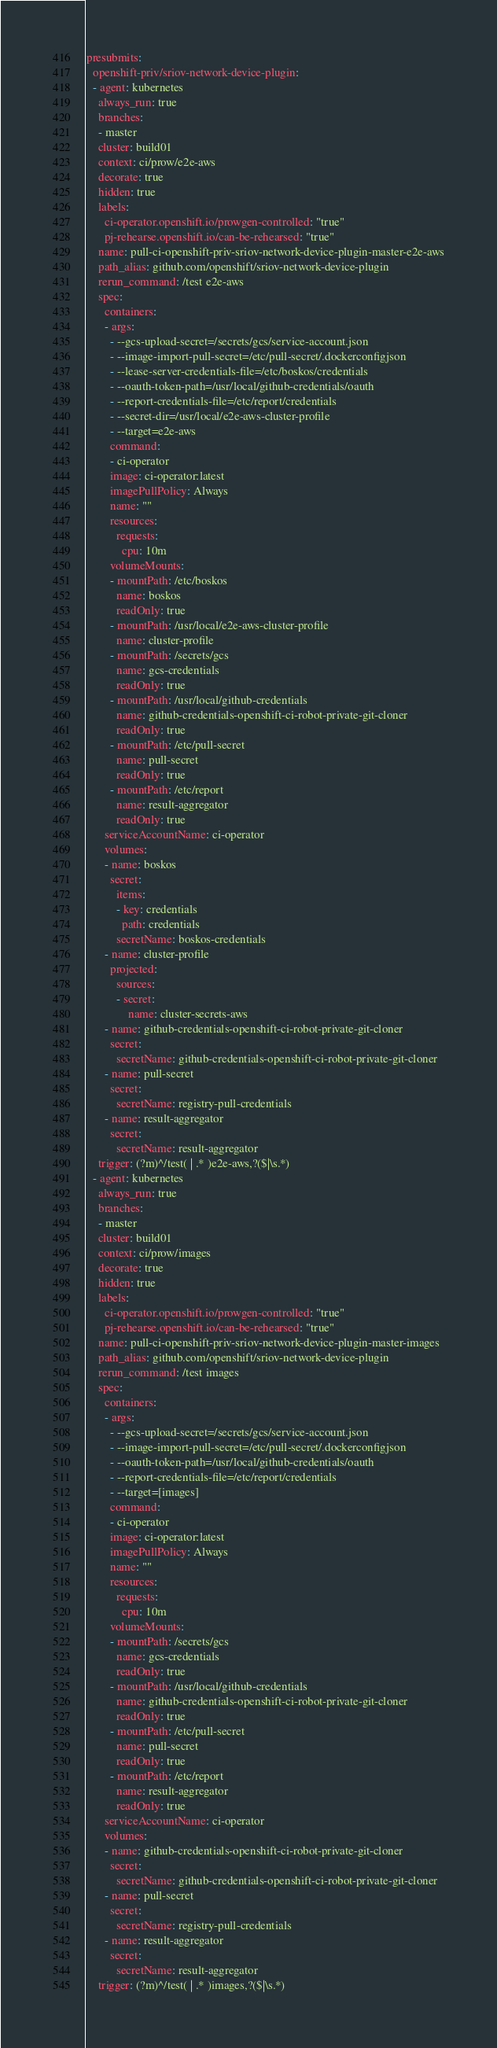Convert code to text. <code><loc_0><loc_0><loc_500><loc_500><_YAML_>presubmits:
  openshift-priv/sriov-network-device-plugin:
  - agent: kubernetes
    always_run: true
    branches:
    - master
    cluster: build01
    context: ci/prow/e2e-aws
    decorate: true
    hidden: true
    labels:
      ci-operator.openshift.io/prowgen-controlled: "true"
      pj-rehearse.openshift.io/can-be-rehearsed: "true"
    name: pull-ci-openshift-priv-sriov-network-device-plugin-master-e2e-aws
    path_alias: github.com/openshift/sriov-network-device-plugin
    rerun_command: /test e2e-aws
    spec:
      containers:
      - args:
        - --gcs-upload-secret=/secrets/gcs/service-account.json
        - --image-import-pull-secret=/etc/pull-secret/.dockerconfigjson
        - --lease-server-credentials-file=/etc/boskos/credentials
        - --oauth-token-path=/usr/local/github-credentials/oauth
        - --report-credentials-file=/etc/report/credentials
        - --secret-dir=/usr/local/e2e-aws-cluster-profile
        - --target=e2e-aws
        command:
        - ci-operator
        image: ci-operator:latest
        imagePullPolicy: Always
        name: ""
        resources:
          requests:
            cpu: 10m
        volumeMounts:
        - mountPath: /etc/boskos
          name: boskos
          readOnly: true
        - mountPath: /usr/local/e2e-aws-cluster-profile
          name: cluster-profile
        - mountPath: /secrets/gcs
          name: gcs-credentials
          readOnly: true
        - mountPath: /usr/local/github-credentials
          name: github-credentials-openshift-ci-robot-private-git-cloner
          readOnly: true
        - mountPath: /etc/pull-secret
          name: pull-secret
          readOnly: true
        - mountPath: /etc/report
          name: result-aggregator
          readOnly: true
      serviceAccountName: ci-operator
      volumes:
      - name: boskos
        secret:
          items:
          - key: credentials
            path: credentials
          secretName: boskos-credentials
      - name: cluster-profile
        projected:
          sources:
          - secret:
              name: cluster-secrets-aws
      - name: github-credentials-openshift-ci-robot-private-git-cloner
        secret:
          secretName: github-credentials-openshift-ci-robot-private-git-cloner
      - name: pull-secret
        secret:
          secretName: registry-pull-credentials
      - name: result-aggregator
        secret:
          secretName: result-aggregator
    trigger: (?m)^/test( | .* )e2e-aws,?($|\s.*)
  - agent: kubernetes
    always_run: true
    branches:
    - master
    cluster: build01
    context: ci/prow/images
    decorate: true
    hidden: true
    labels:
      ci-operator.openshift.io/prowgen-controlled: "true"
      pj-rehearse.openshift.io/can-be-rehearsed: "true"
    name: pull-ci-openshift-priv-sriov-network-device-plugin-master-images
    path_alias: github.com/openshift/sriov-network-device-plugin
    rerun_command: /test images
    spec:
      containers:
      - args:
        - --gcs-upload-secret=/secrets/gcs/service-account.json
        - --image-import-pull-secret=/etc/pull-secret/.dockerconfigjson
        - --oauth-token-path=/usr/local/github-credentials/oauth
        - --report-credentials-file=/etc/report/credentials
        - --target=[images]
        command:
        - ci-operator
        image: ci-operator:latest
        imagePullPolicy: Always
        name: ""
        resources:
          requests:
            cpu: 10m
        volumeMounts:
        - mountPath: /secrets/gcs
          name: gcs-credentials
          readOnly: true
        - mountPath: /usr/local/github-credentials
          name: github-credentials-openshift-ci-robot-private-git-cloner
          readOnly: true
        - mountPath: /etc/pull-secret
          name: pull-secret
          readOnly: true
        - mountPath: /etc/report
          name: result-aggregator
          readOnly: true
      serviceAccountName: ci-operator
      volumes:
      - name: github-credentials-openshift-ci-robot-private-git-cloner
        secret:
          secretName: github-credentials-openshift-ci-robot-private-git-cloner
      - name: pull-secret
        secret:
          secretName: registry-pull-credentials
      - name: result-aggregator
        secret:
          secretName: result-aggregator
    trigger: (?m)^/test( | .* )images,?($|\s.*)
</code> 